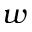Convert formula to latex. <formula><loc_0><loc_0><loc_500><loc_500>w</formula> 